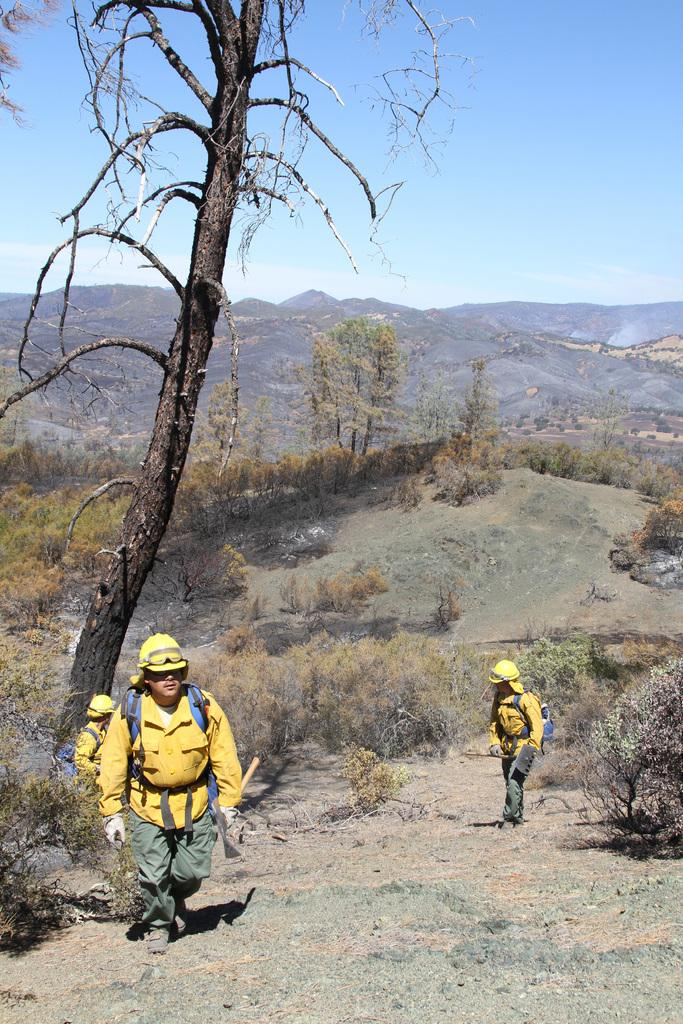How many people are in the image? There are three persons in the image. Where are the persons located? The persons are on a rock in the image. What type of vegetation can be seen in the image? There are plants and trees in the image. What can be seen in the background of the image? There are mountains and the sky visible in the background of the image. What type of bucket is being used to create harmony among the mountains in the image? There is no bucket present in the image, and the mountains are not being used to create harmony. 